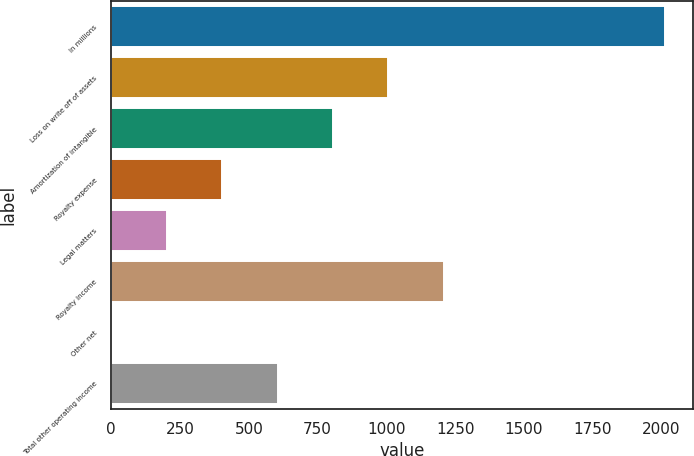<chart> <loc_0><loc_0><loc_500><loc_500><bar_chart><fcel>In millions<fcel>Loss on write off of assets<fcel>Amortization of intangible<fcel>Royalty expense<fcel>Legal matters<fcel>Royalty income<fcel>Other net<fcel>Total other operating income<nl><fcel>2013<fcel>1007<fcel>805.8<fcel>403.4<fcel>202.2<fcel>1208.2<fcel>1<fcel>604.6<nl></chart> 